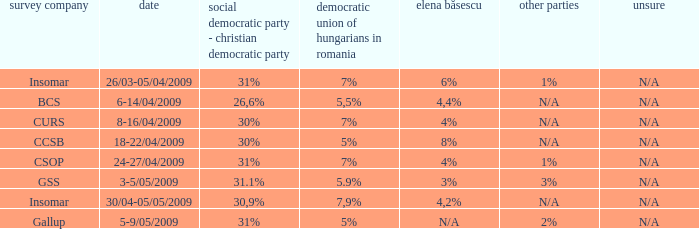What was the polling firm with others of 1%? Insomar, CSOP. 